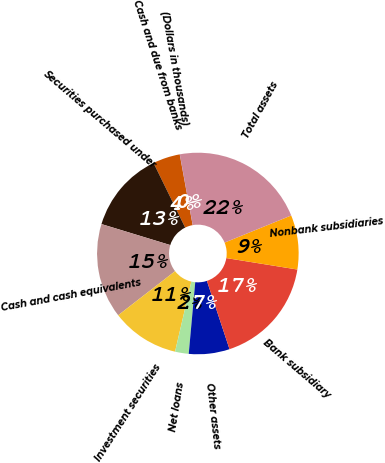Convert chart. <chart><loc_0><loc_0><loc_500><loc_500><pie_chart><fcel>(Dollars in thousands)<fcel>Cash and due from banks<fcel>Securities purchased under<fcel>Cash and cash equivalents<fcel>Investment securities<fcel>Net loans<fcel>Other assets<fcel>Bank subsidiary<fcel>Nonbank subsidiaries<fcel>Total assets<nl><fcel>0.02%<fcel>4.36%<fcel>13.04%<fcel>15.21%<fcel>10.87%<fcel>2.19%<fcel>6.53%<fcel>17.37%<fcel>8.7%<fcel>21.71%<nl></chart> 